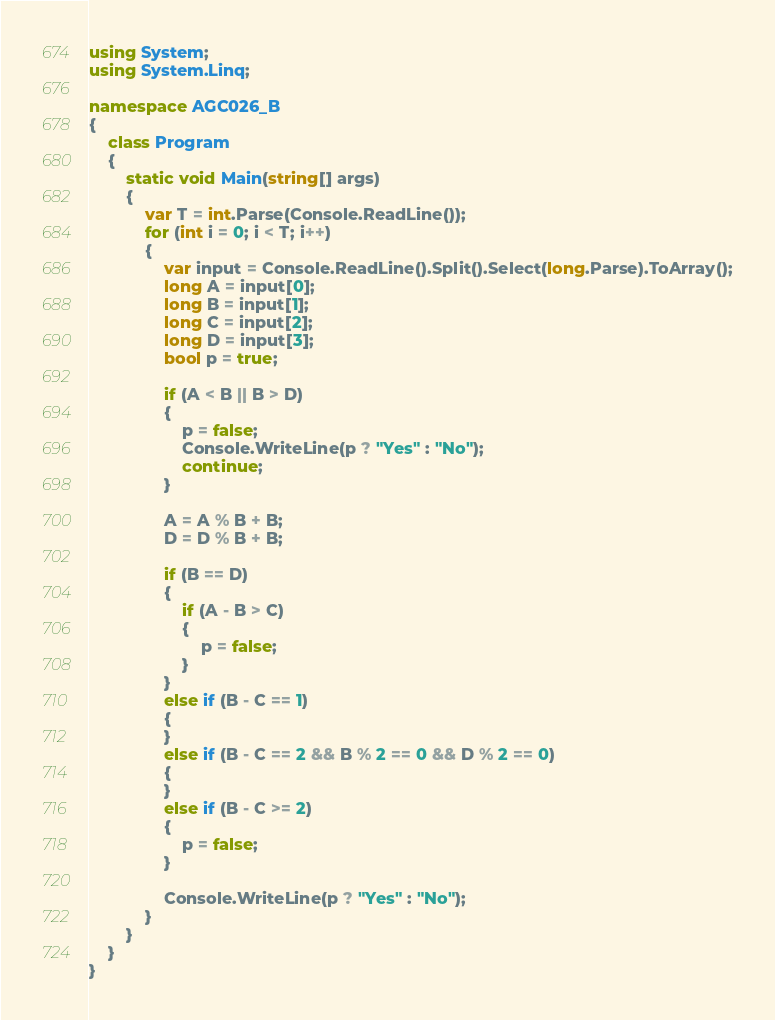<code> <loc_0><loc_0><loc_500><loc_500><_C#_>using System;
using System.Linq;

namespace AGC026_B
{
    class Program
    {
        static void Main(string[] args)
        {
            var T = int.Parse(Console.ReadLine());
            for (int i = 0; i < T; i++)
            {
                var input = Console.ReadLine().Split().Select(long.Parse).ToArray();
                long A = input[0];
                long B = input[1];
                long C = input[2];
                long D = input[3];
                bool p = true;

                if (A < B || B > D)
                {
                    p = false;
                    Console.WriteLine(p ? "Yes" : "No");
                    continue;
                }

                A = A % B + B;
                D = D % B + B;

                if (B == D)
                {
                    if (A - B > C)
                    {
                        p = false;
                    }
                }
                else if (B - C == 1)
                {
                }
                else if (B - C == 2 && B % 2 == 0 && D % 2 == 0)
                {
                }
                else if (B - C >= 2)
                {
                    p = false;
                }

                Console.WriteLine(p ? "Yes" : "No");
            }
        }
    }
}</code> 